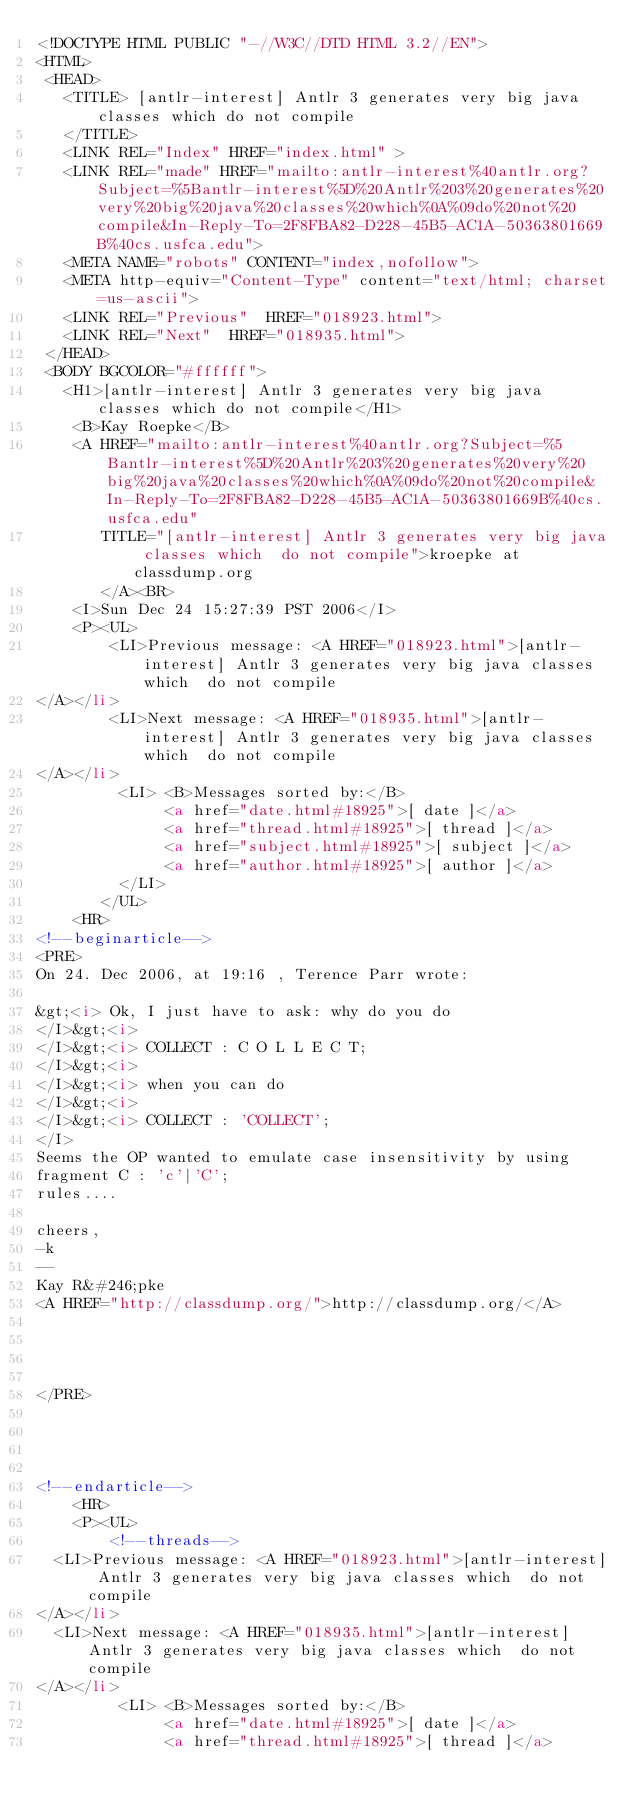Convert code to text. <code><loc_0><loc_0><loc_500><loc_500><_HTML_><!DOCTYPE HTML PUBLIC "-//W3C//DTD HTML 3.2//EN">
<HTML>
 <HEAD>
   <TITLE> [antlr-interest] Antlr 3 generates very big java classes which	do not compile
   </TITLE>
   <LINK REL="Index" HREF="index.html" >
   <LINK REL="made" HREF="mailto:antlr-interest%40antlr.org?Subject=%5Bantlr-interest%5D%20Antlr%203%20generates%20very%20big%20java%20classes%20which%0A%09do%20not%20compile&In-Reply-To=2F8FBA82-D228-45B5-AC1A-50363801669B%40cs.usfca.edu">
   <META NAME="robots" CONTENT="index,nofollow">
   <META http-equiv="Content-Type" content="text/html; charset=us-ascii">
   <LINK REL="Previous"  HREF="018923.html">
   <LINK REL="Next"  HREF="018935.html">
 </HEAD>
 <BODY BGCOLOR="#ffffff">
   <H1>[antlr-interest] Antlr 3 generates very big java classes which	do not compile</H1>
    <B>Kay Roepke</B> 
    <A HREF="mailto:antlr-interest%40antlr.org?Subject=%5Bantlr-interest%5D%20Antlr%203%20generates%20very%20big%20java%20classes%20which%0A%09do%20not%20compile&In-Reply-To=2F8FBA82-D228-45B5-AC1A-50363801669B%40cs.usfca.edu"
       TITLE="[antlr-interest] Antlr 3 generates very big java classes which	do not compile">kroepke at classdump.org
       </A><BR>
    <I>Sun Dec 24 15:27:39 PST 2006</I>
    <P><UL>
        <LI>Previous message: <A HREF="018923.html">[antlr-interest] Antlr 3 generates very big java classes which	do not compile
</A></li>
        <LI>Next message: <A HREF="018935.html">[antlr-interest] Antlr 3 generates very big java classes which	do not compile
</A></li>
         <LI> <B>Messages sorted by:</B> 
              <a href="date.html#18925">[ date ]</a>
              <a href="thread.html#18925">[ thread ]</a>
              <a href="subject.html#18925">[ subject ]</a>
              <a href="author.html#18925">[ author ]</a>
         </LI>
       </UL>
    <HR>  
<!--beginarticle-->
<PRE>
On 24. Dec 2006, at 19:16 , Terence Parr wrote:

&gt;<i> Ok, I just have to ask: why do you do
</I>&gt;<i>
</I>&gt;<i> COLLECT : C O L L E C T;
</I>&gt;<i>
</I>&gt;<i> when you can do
</I>&gt;<i>
</I>&gt;<i> COLLECT : 'COLLECT';
</I>
Seems the OP wanted to emulate case insensitivity by using
fragment C : 'c'|'C';
rules....

cheers,
-k
-- 
Kay R&#246;pke
<A HREF="http://classdump.org/">http://classdump.org/</A>




</PRE>




<!--endarticle-->
    <HR>
    <P><UL>
        <!--threads-->
	<LI>Previous message: <A HREF="018923.html">[antlr-interest] Antlr 3 generates very big java classes which	do not compile
</A></li>
	<LI>Next message: <A HREF="018935.html">[antlr-interest] Antlr 3 generates very big java classes which	do not compile
</A></li>
         <LI> <B>Messages sorted by:</B> 
              <a href="date.html#18925">[ date ]</a>
              <a href="thread.html#18925">[ thread ]</a></code> 